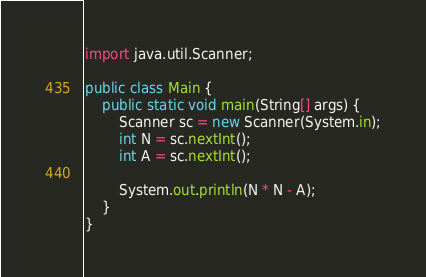Convert code to text. <code><loc_0><loc_0><loc_500><loc_500><_Java_>import java.util.Scanner;

public class Main {
	public static void main(String[] args) {
		Scanner sc = new Scanner(System.in);
		int N = sc.nextInt();
		int A = sc.nextInt();
		
		System.out.println(N * N - A);
	}
}
</code> 